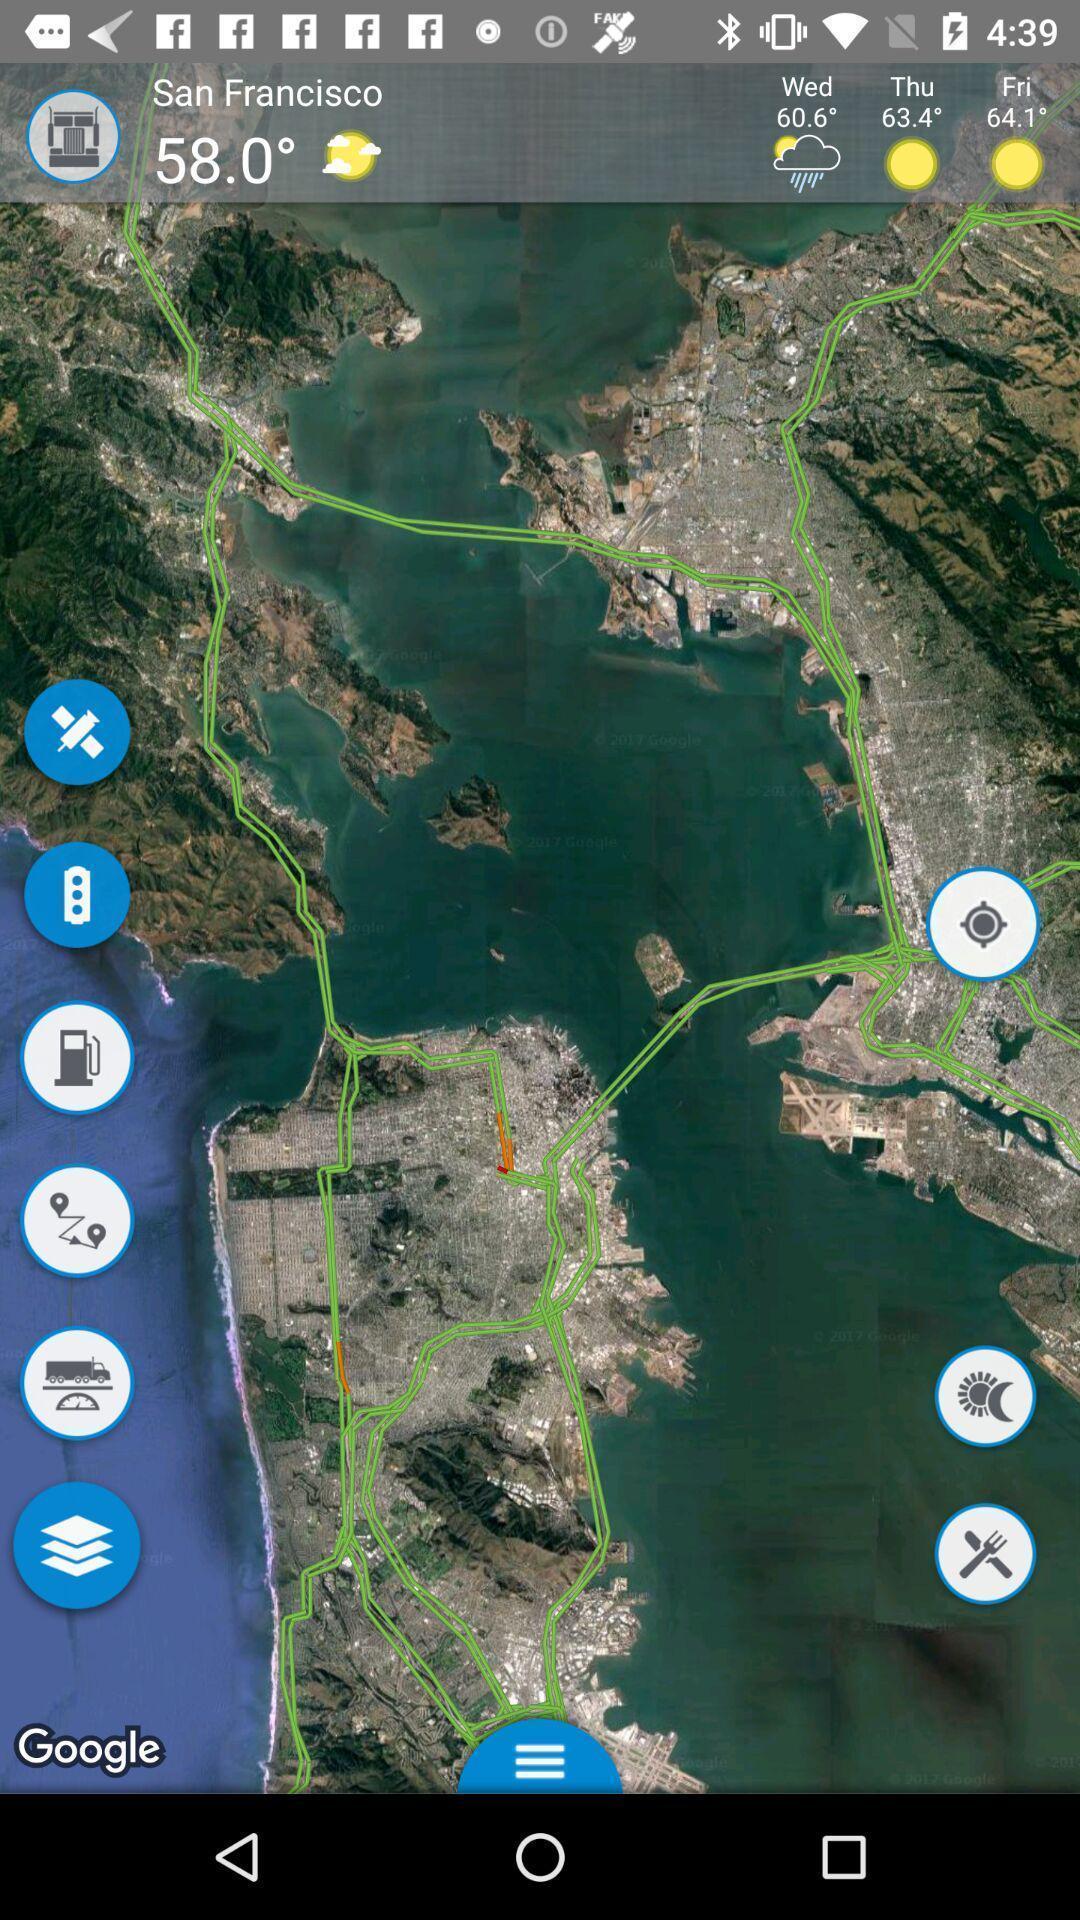Provide a description of this screenshot. Page that displaying gps application. 